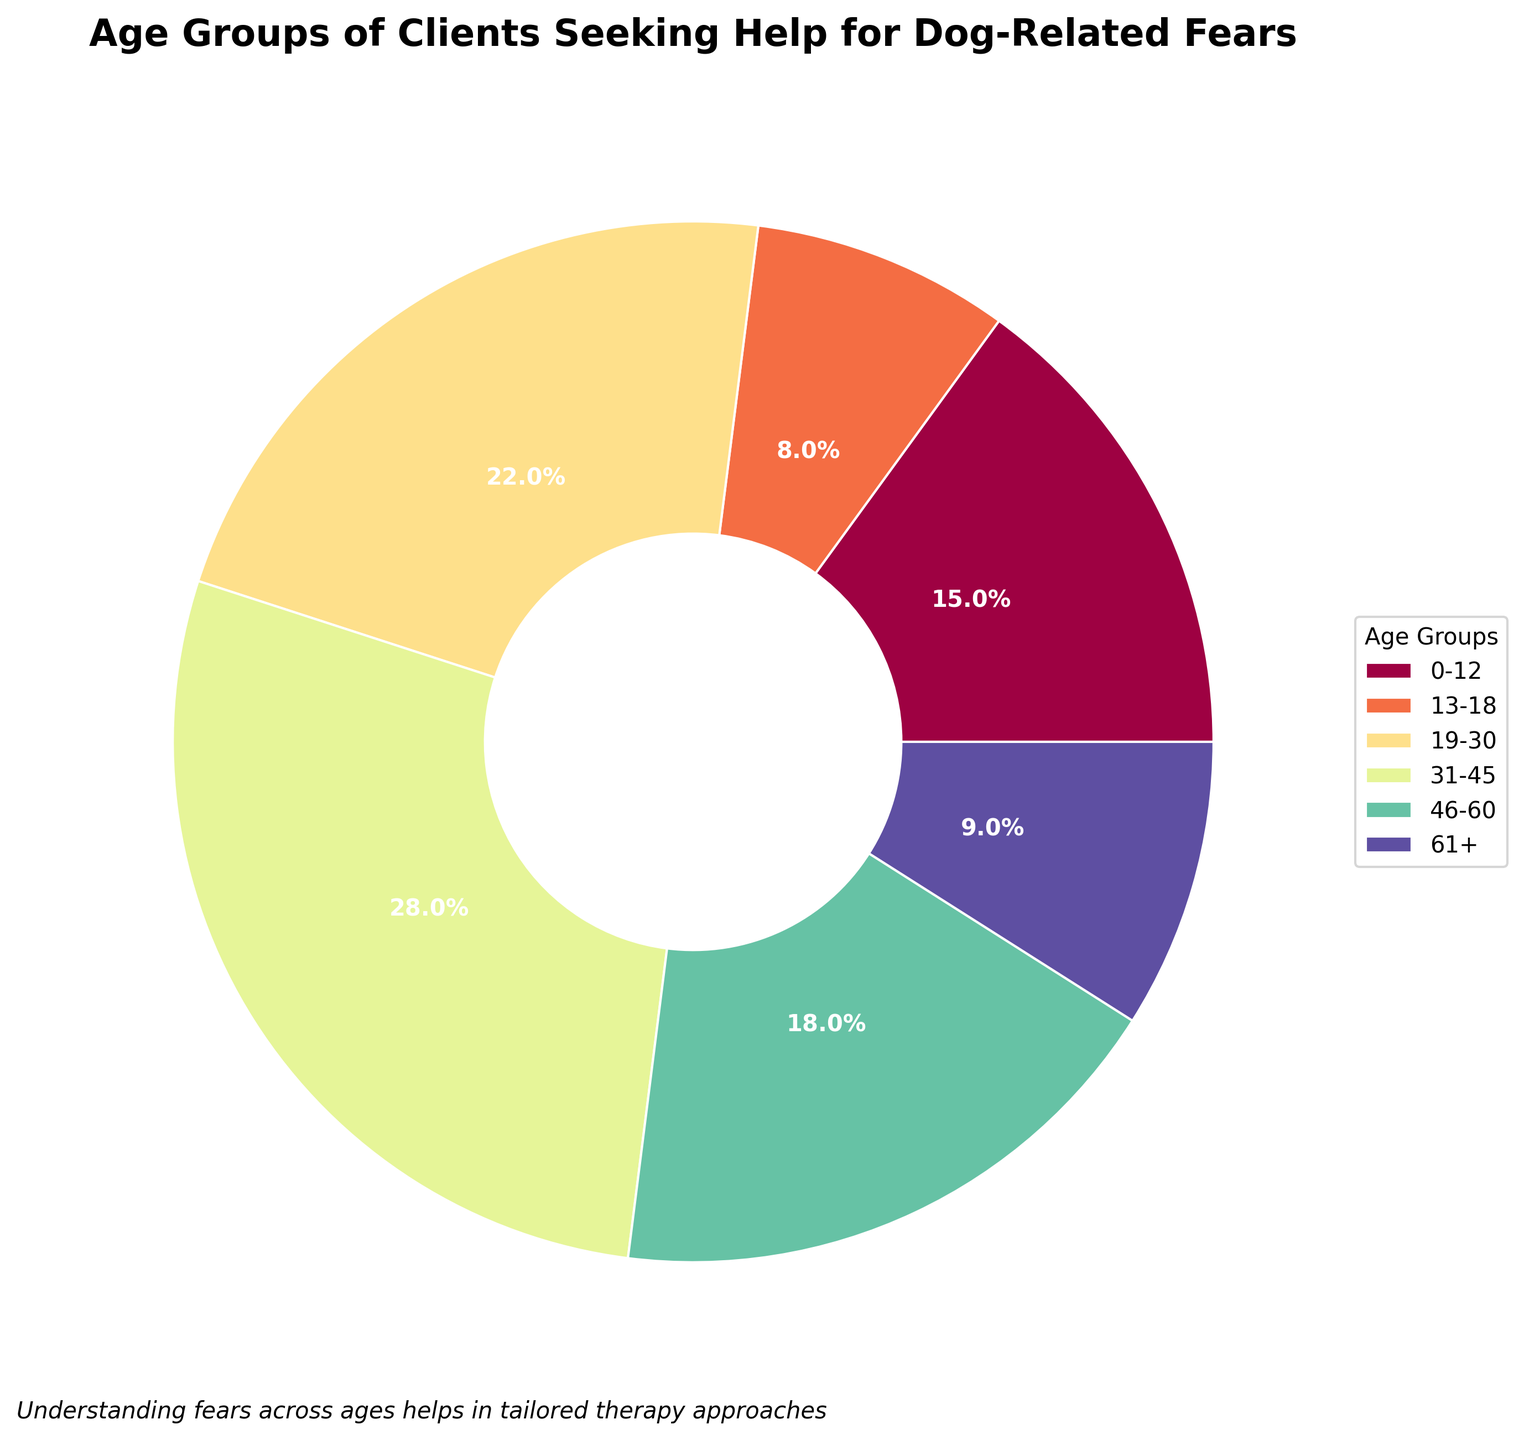What percentage of clients are in the 31-45 age group? Look at the segment labeled "31-45" in the pie chart and read the percentage value displayed for this segment.
Answer: 28% Which age group has the smallest percentage of clients? Review each segment in the pie chart and identify the one with the smallest percentage value displayed.
Answer: 13-18 Does the combined percentage of clients in the 0-12 and 61+ age groups exceed the percentage of the 31-45 age group? The 0-12 group has 15% and the 61+ group has 9%. Adding these together gives 15% + 9% = 24%, which is less than the 31-45 group’s 28%.
Answer: No What is the difference in the percentage of clients between the 19-30 age group and the 46-60 age group? The percentage for the 19-30 group is 22% and for the 46-60 group is 18%. Subtract the smaller percentage from the larger one: 22% - 18% = 4%.
Answer: 4% How many age groups have a percentage greater than 20%? Identify the segments in the pie chart with percentages over 20%. The groups are 19-30 (22%) and 31-45 (28%).
Answer: 2 Which age group represents approximately one-fifth of the total clients? Calculate one-fifth of 100%, which is 20%. Identify the segment(s) in the pie chart closest to this value. The 19-30 age group (22%) is closest.
Answer: 19-30 Is the percentage of clients in the 13-18 age group less than half of those in the 46-60 age group? The percentage for 13-18 is 8% and for 46-60 is 18%. Half of 18% is 9%, and 8% is less than 9%.
Answer: Yes Which age group has a percentage just under a quarter of the total clients? A quarter of 100% is 25%. Identify which segment in the pie chart has a percentage slightly below this value. The 19-30 group (22%) is the closest.
Answer: 19-30 What is the total percentage of clients in the age groups from 31-60? Add the percentages for the 31-45 group (28%) and the 46-60 group (18%). 28% + 18% = 46%.
Answer: 46% Which age group is represented with a light color near the top right of the pie chart? Visually identify the pale or light-colored segment positioned around the top right of the pie chart, labeled "61+".
Answer: 61+ 